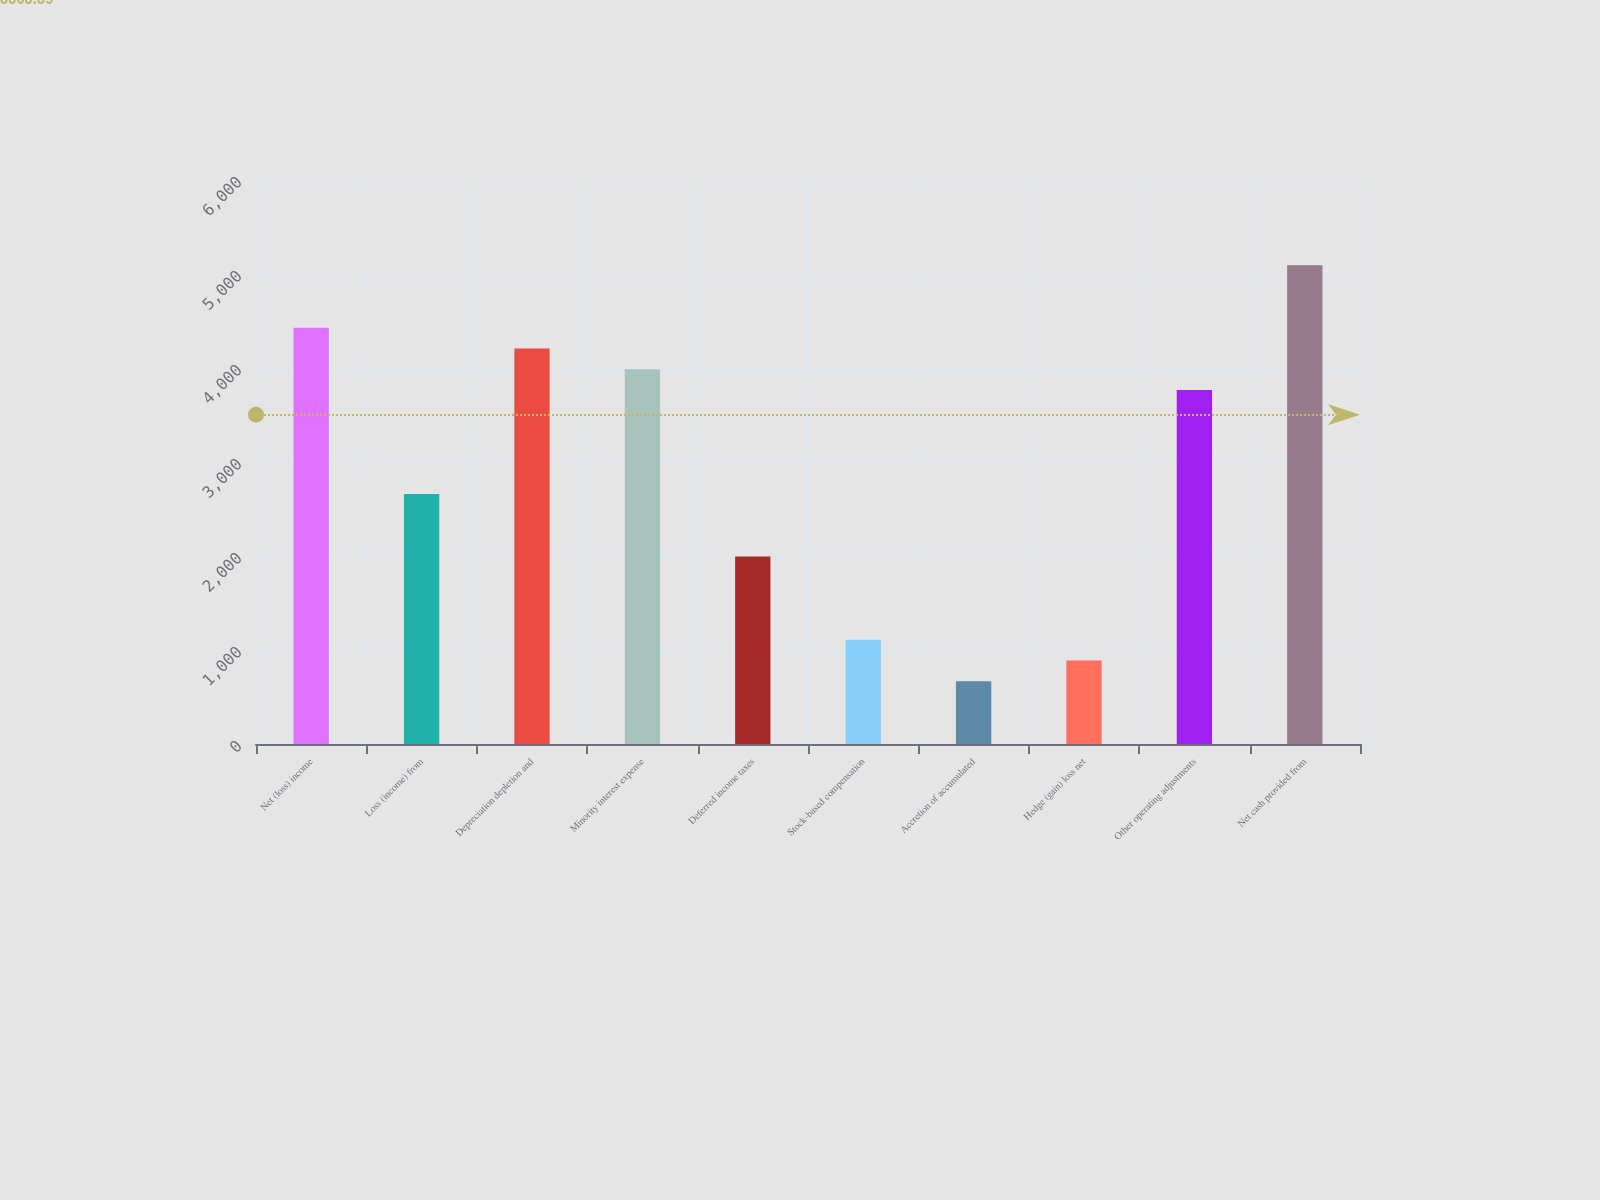<chart> <loc_0><loc_0><loc_500><loc_500><bar_chart><fcel>Net (loss) income<fcel>Loss (income) from<fcel>Depreciation depletion and<fcel>Minority interest expense<fcel>Deferred income taxes<fcel>Stock-based compensation<fcel>Accretion of accumulated<fcel>Hedge (gain) loss net<fcel>Other operating adjustments<fcel>Net cash provided from<nl><fcel>4429<fcel>2658.6<fcel>4207.7<fcel>3986.4<fcel>1994.7<fcel>1109.5<fcel>666.9<fcel>888.2<fcel>3765.1<fcel>5092.9<nl></chart> 